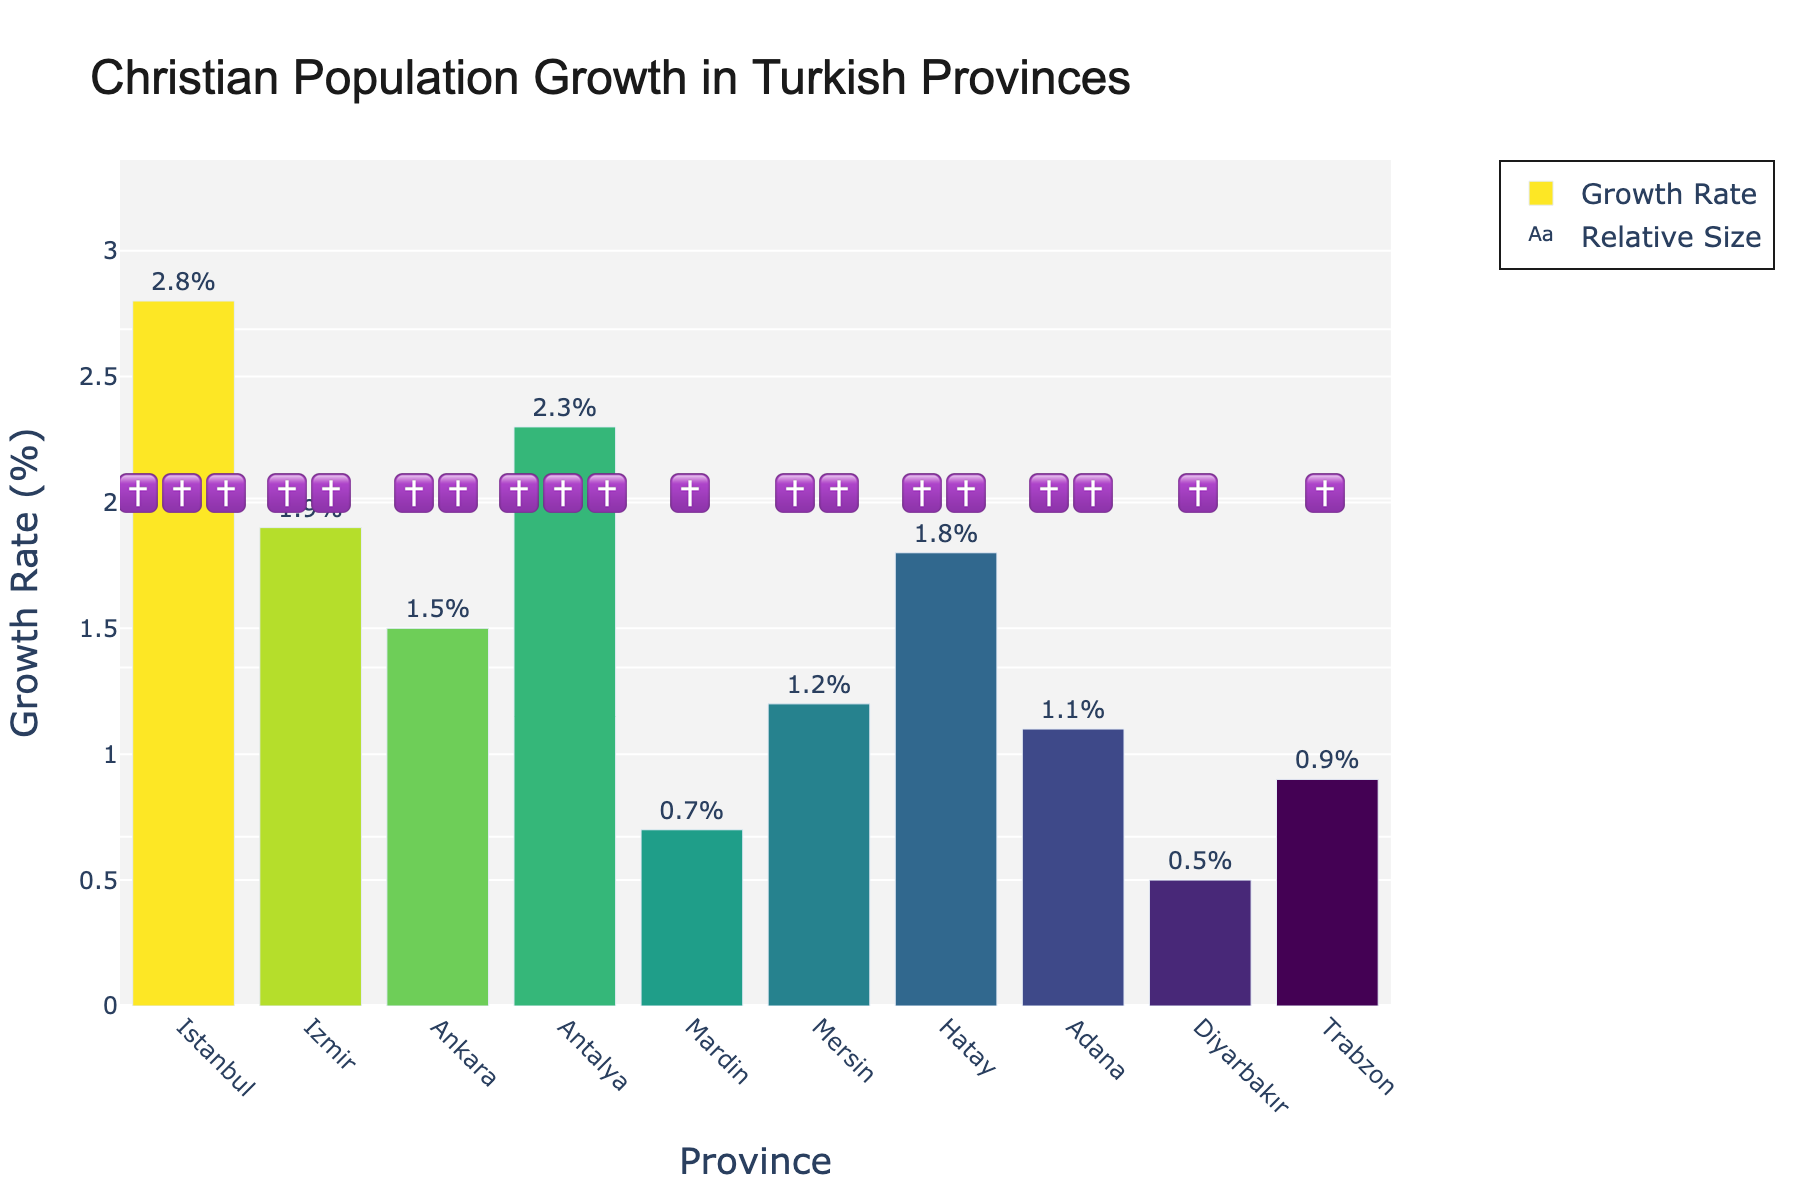what is the christian population growth rate in Izmir? To find the growth rate for Izmir, look for the bar representing Izmir on the x-axis and check its length on the y-axis. The value is also labeled on top of the bar.
Answer: 1.9% how many provinces have a growth rate of 1.0% or higher? Count the bars whose values on top show a growth rate of 1.0% or more.
Answer: 7 which province has the lowest christian population growth rate and what is that rate? Look for the shortest bar on the chart and read the value on top of it.
Answer: Diyarbakır, 0.5% what is the difference in growth rate between Istanbul and Mardin? Read the values on top of the bars for Istanbul and Mardin and subtract the smaller value from the larger value.
Answer: 2.1% which provinces have three crosses (✝️✝️✝️) representing their christian population growth? Identify the scatter points with three cross emojis and check the provinces they align with on the x-axis.
Answer: Istanbul, Antalya how does the christian population growth rate in Trabzon compare to that in Hatay? Read the values on top of the bars for Trabzon and Hatay, then compare them.
Answer: Trabzon is lower what is the average christian population growth rate across all the provinces? Add up all the growth rates and divide by the number of provinces: (2.8+1.9+1.5+2.3+0.7+1.2+1.8+1.1+0.5+0.9) / 10 = 1.47%
Answer: 1.47% which province has a higher growth rate, Mersin or Adana? Compare the values on top of the bars for Mersin and Adana.
Answer: Mersin how many emojis are used in total to represent the growth rates? Count all the crosses across each scatter point for all provinces.
Answer: 16 